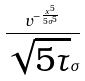<formula> <loc_0><loc_0><loc_500><loc_500>\frac { v ^ { - \frac { x ^ { 5 } } { 5 \sigma ^ { 5 } } } } { \sqrt { 5 \tau } \sigma }</formula> 